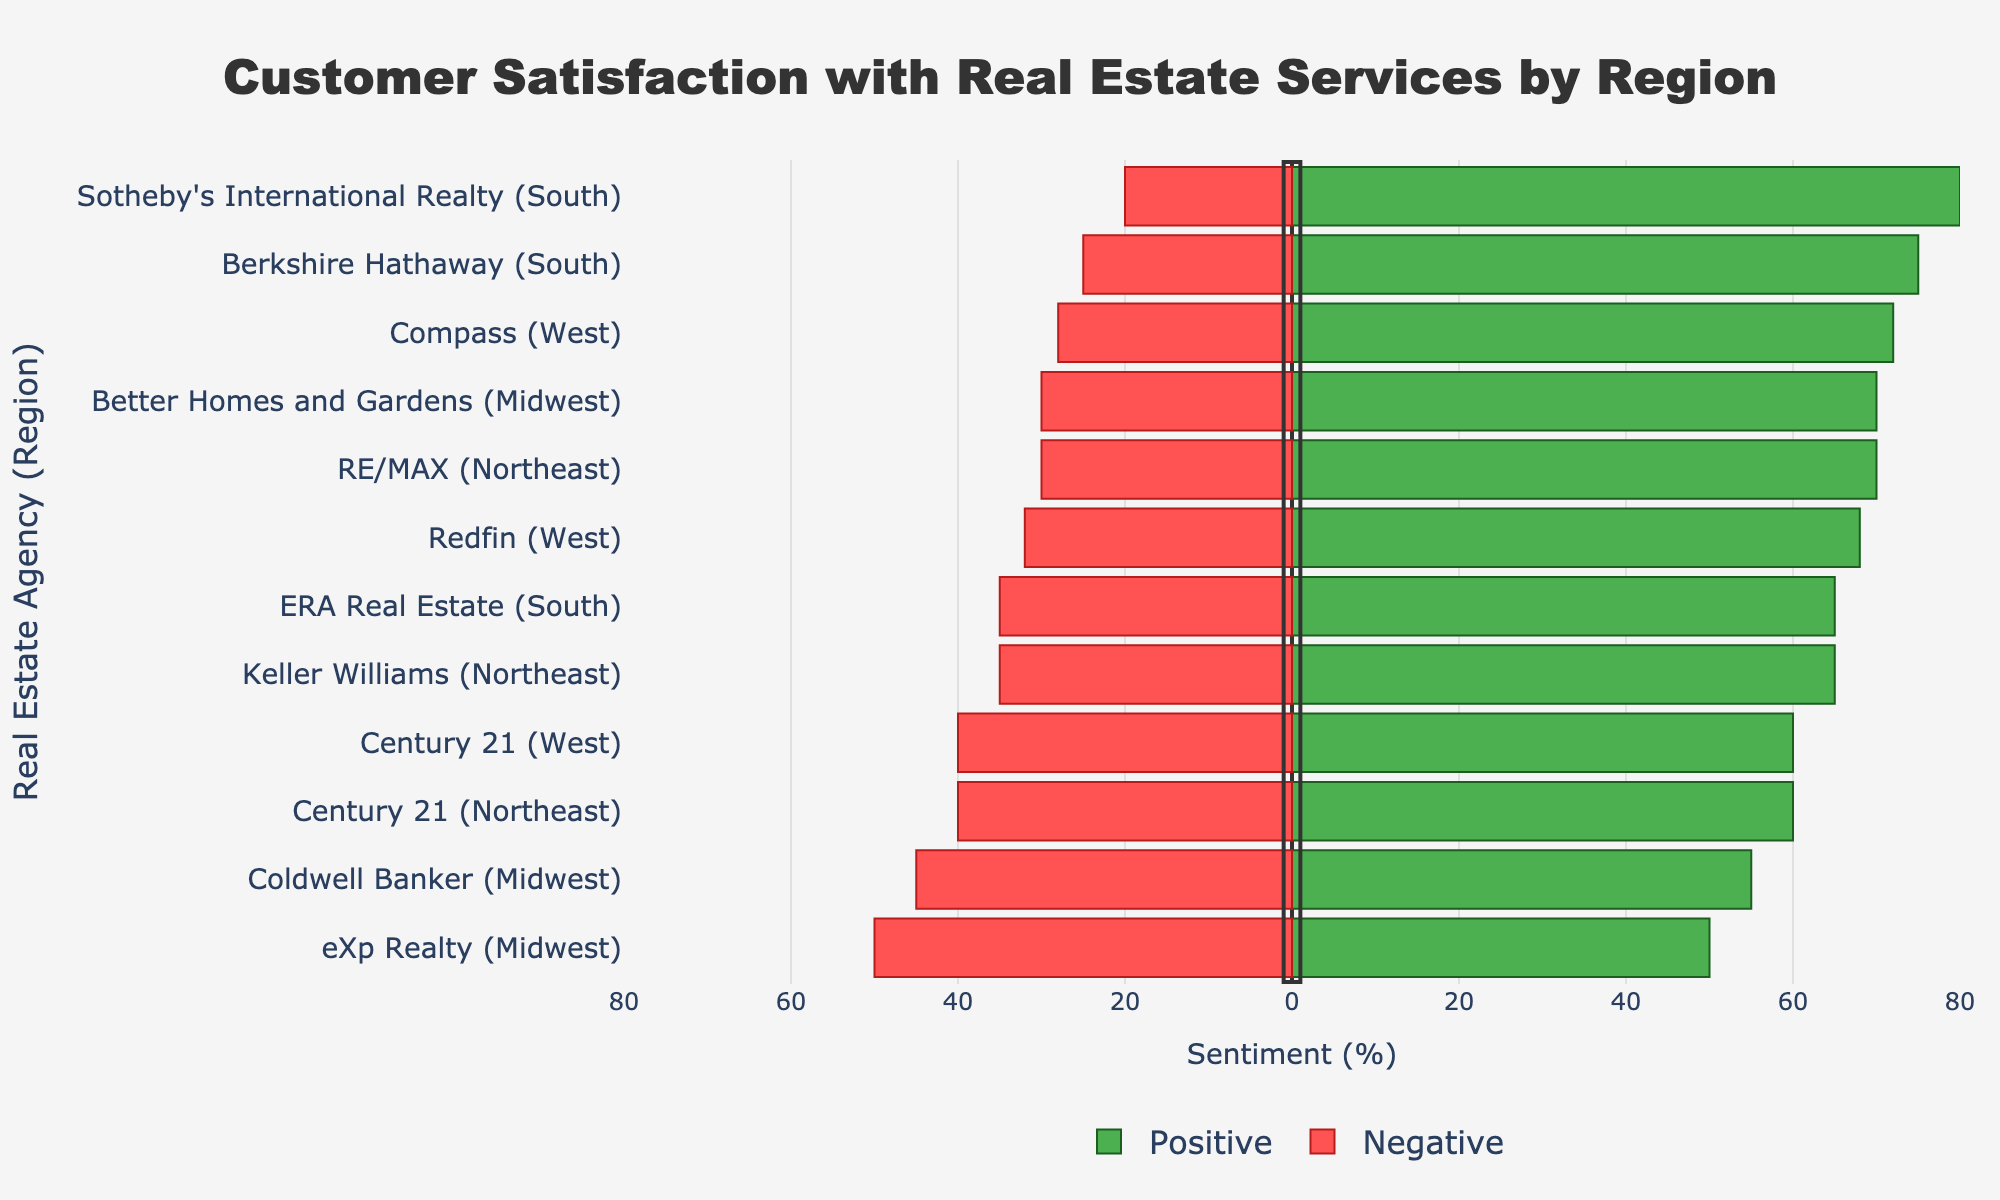Why is the Positive bar longer for Sotheby's International Realty in the South region than any other bar? Sotheby's International Realty has a Positive Sentiment of 80%, which is the highest percentage among all the agencies in all regions. This makes its Positive bar longest.
Answer: Highest Positive Sentiment Which agency in the Midwest region has the smallest Negative Sentiment? Better Homes and Gardens in the Midwest region has the smallest Negative Sentiment of 30%. This is visually represented by the shortest red (negative) bar among the Midwest agencies.
Answer: Better Homes and Gardens What is the difference in Positive Sentiment between the highest and lowest agency in the South region? In the South region, Sotheby's International Realty has the highest Positive Sentiment (80%) and ERA Real Estate has the lowest (65%). The difference is 80% - 65% = 15%.
Answer: 15% Among the Northeast region agencies, which one has a higher Negative Sentiment, Century 21 or Keller Williams? Century 21 and Keller Williams in the Northeast have Negative Sentiments of 40% and 35% respectively. Therefore, Century 21 has a higher Negative Sentiment.
Answer: Century 21 Which agency has the most balanced Positive and Negative Sentiment and in which region? eXp Realty in the Midwest has a 50% Positive Sentiment and 50% Negative Sentiment, making it the most balanced among all agencies across regions.
Answer: eXp Realty in the Midwest 